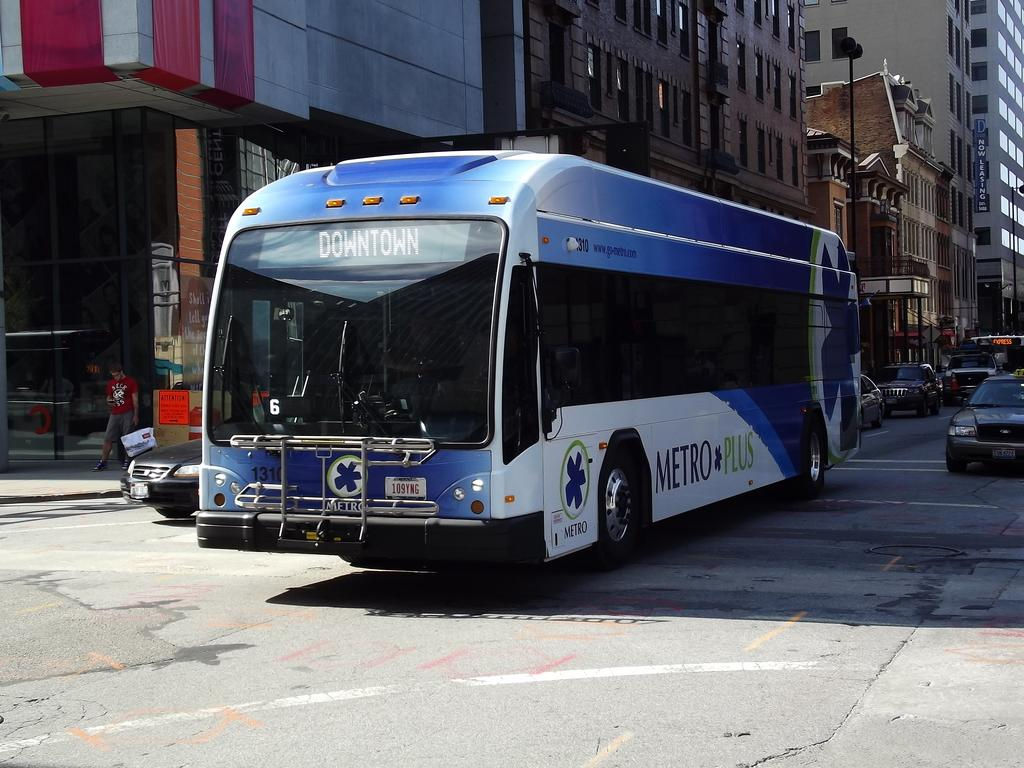Where was the image taken? The image was taken on the road. What is the main subject in the center of the image? There is a bus in the center of the image. What other vehicles can be seen on the road? There are cars on the road. What is visible on the left side of the image? There are buildings on the left side of the image. What part of the road is visible in the image? The road is visible at the bottom of the image. How many pieces of lumber can be seen stacked on the bus in the image? There is no lumber visible in the image; it features a bus, cars, and buildings on the road. 